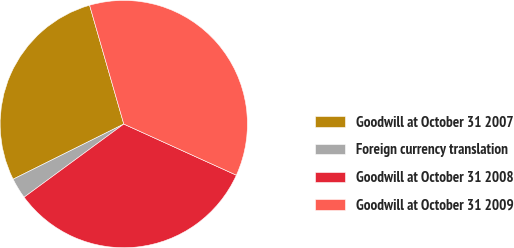Convert chart. <chart><loc_0><loc_0><loc_500><loc_500><pie_chart><fcel>Goodwill at October 31 2007<fcel>Foreign currency translation<fcel>Goodwill at October 31 2008<fcel>Goodwill at October 31 2009<nl><fcel>27.9%<fcel>2.72%<fcel>33.14%<fcel>36.25%<nl></chart> 